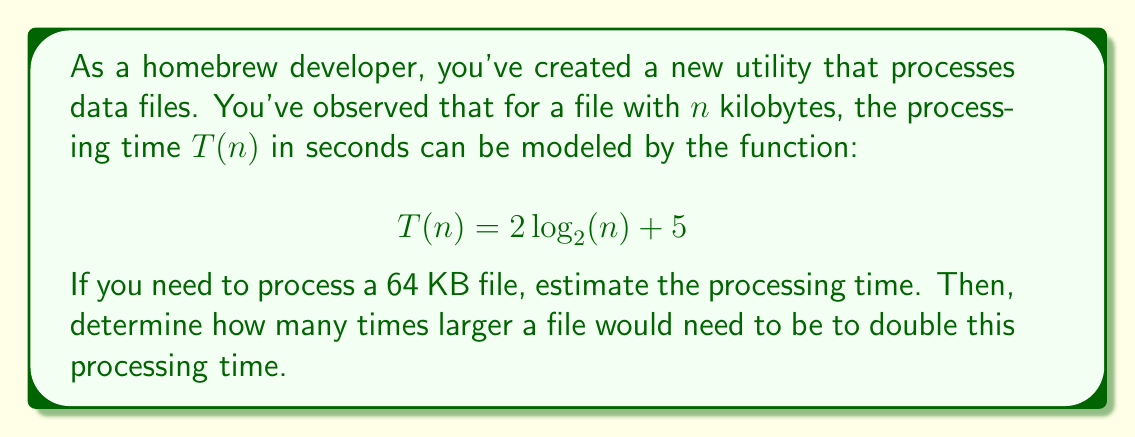What is the answer to this math problem? Let's approach this problem step by step:

1) First, we need to calculate the processing time for a 64 KB file:

   $$T(64) = 2\log_2(64) + 5$$

   To solve this, let's recall that $64 = 2^6$, so $\log_2(64) = 6$

   $$T(64) = 2(6) + 5 = 12 + 5 = 17$$

   Therefore, it would take 17 seconds to process a 64 KB file.

2) Now, let's consider how much larger the file needs to be to double this processing time. Let's call the new file size $x$ KB.

   We want: $T(x) = 2T(64) = 2(17) = 34$

   So, we need to solve:

   $$2\log_2(x) + 5 = 34$$

3) Let's solve this equation:

   $$2\log_2(x) + 5 = 34$$
   $$2\log_2(x) = 29$$
   $$\log_2(x) = 14.5$$

4) To solve for $x$, we need to apply $2$ to both sides:

   $$x = 2^{14.5} \approx 23,170$$

5) To find how many times larger this is than the original file:

   $$\frac{23,170}{64} \approx 362$$

Therefore, the file would need to be approximately 362 times larger to double the processing time.
Answer: The processing time for a 64 KB file is 17 seconds. To double this processing time to 34 seconds, the file would need to be approximately 362 times larger, or about 23,170 KB. 